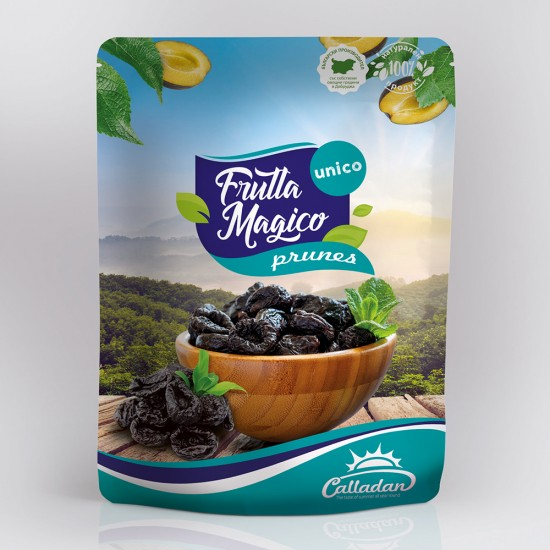What could the significance of the lemon slices and mint leaves be in relation to the prunes? The use of lemon slices and mint leaves alongside the prunes in the image likely serves a dual purpose. Firstly, they suggest a flavorful combination where the tangy zest of lemon and the refreshing hint of mint could complement the naturally sweet and deep flavors of the prunes, enhancing the overall taste experience. Secondly, this setup might be showcasing a serving suggestion or a culinary inspiration for consumers, hinting at creative ways to incorporate these prunes into dishes or beverages. It serves not only as a visual enhancement but also invites the audience to think of the prunes beyond a typical snack, integrating them into more diverse and appealing culinary contexts. 